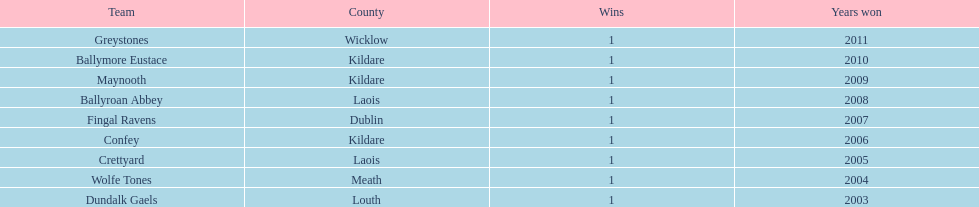Which team triumphed before crettyard? Wolfe Tones. Write the full table. {'header': ['Team', 'County', 'Wins', 'Years won'], 'rows': [['Greystones', 'Wicklow', '1', '2011'], ['Ballymore Eustace', 'Kildare', '1', '2010'], ['Maynooth', 'Kildare', '1', '2009'], ['Ballyroan Abbey', 'Laois', '1', '2008'], ['Fingal Ravens', 'Dublin', '1', '2007'], ['Confey', 'Kildare', '1', '2006'], ['Crettyard', 'Laois', '1', '2005'], ['Wolfe Tones', 'Meath', '1', '2004'], ['Dundalk Gaels', 'Louth', '1', '2003']]} 